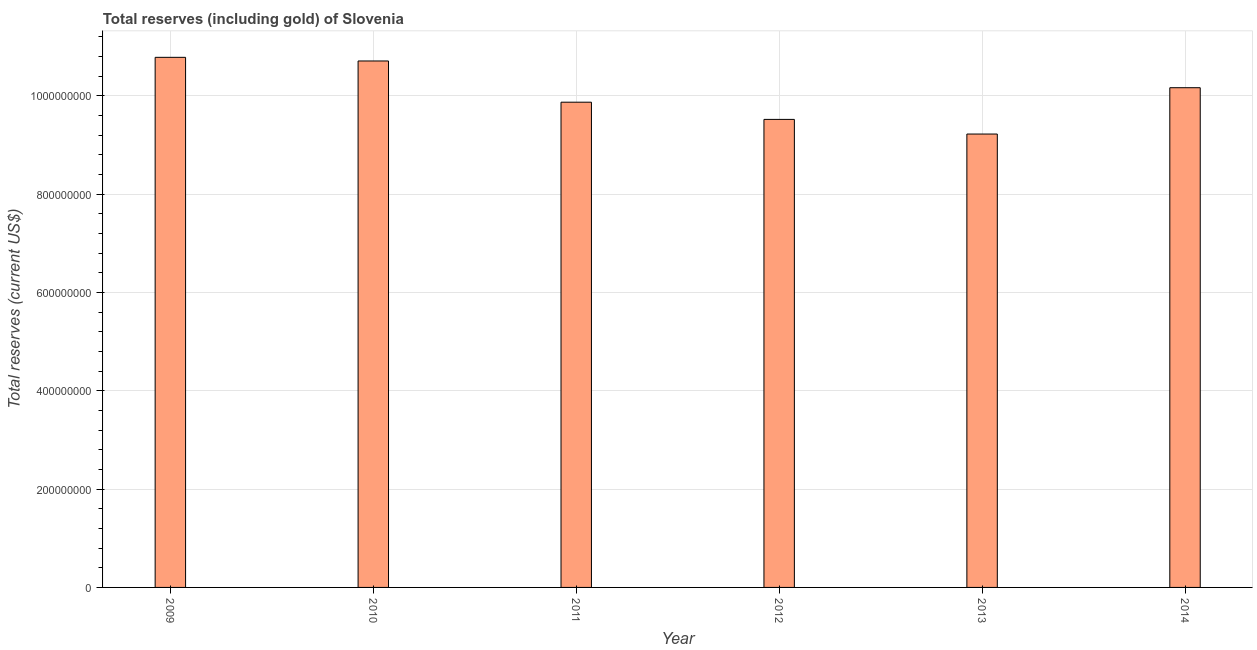Does the graph contain grids?
Provide a succinct answer. Yes. What is the title of the graph?
Provide a short and direct response. Total reserves (including gold) of Slovenia. What is the label or title of the Y-axis?
Make the answer very short. Total reserves (current US$). What is the total reserves (including gold) in 2012?
Make the answer very short. 9.52e+08. Across all years, what is the maximum total reserves (including gold)?
Provide a succinct answer. 1.08e+09. Across all years, what is the minimum total reserves (including gold)?
Your response must be concise. 9.22e+08. In which year was the total reserves (including gold) maximum?
Provide a short and direct response. 2009. In which year was the total reserves (including gold) minimum?
Provide a short and direct response. 2013. What is the sum of the total reserves (including gold)?
Ensure brevity in your answer.  6.03e+09. What is the difference between the total reserves (including gold) in 2009 and 2011?
Keep it short and to the point. 9.13e+07. What is the average total reserves (including gold) per year?
Provide a succinct answer. 1.00e+09. What is the median total reserves (including gold)?
Offer a terse response. 1.00e+09. Do a majority of the years between 2014 and 2011 (inclusive) have total reserves (including gold) greater than 120000000 US$?
Keep it short and to the point. Yes. What is the ratio of the total reserves (including gold) in 2009 to that in 2011?
Your response must be concise. 1.09. Is the difference between the total reserves (including gold) in 2010 and 2014 greater than the difference between any two years?
Give a very brief answer. No. What is the difference between the highest and the second highest total reserves (including gold)?
Offer a very short reply. 7.40e+06. Is the sum of the total reserves (including gold) in 2012 and 2014 greater than the maximum total reserves (including gold) across all years?
Provide a succinct answer. Yes. What is the difference between the highest and the lowest total reserves (including gold)?
Your answer should be compact. 1.56e+08. In how many years, is the total reserves (including gold) greater than the average total reserves (including gold) taken over all years?
Make the answer very short. 3. How many bars are there?
Make the answer very short. 6. How many years are there in the graph?
Offer a terse response. 6. What is the Total reserves (current US$) in 2009?
Provide a short and direct response. 1.08e+09. What is the Total reserves (current US$) of 2010?
Your response must be concise. 1.07e+09. What is the Total reserves (current US$) in 2011?
Your response must be concise. 9.87e+08. What is the Total reserves (current US$) in 2012?
Ensure brevity in your answer.  9.52e+08. What is the Total reserves (current US$) in 2013?
Your response must be concise. 9.22e+08. What is the Total reserves (current US$) in 2014?
Your response must be concise. 1.02e+09. What is the difference between the Total reserves (current US$) in 2009 and 2010?
Give a very brief answer. 7.40e+06. What is the difference between the Total reserves (current US$) in 2009 and 2011?
Ensure brevity in your answer.  9.13e+07. What is the difference between the Total reserves (current US$) in 2009 and 2012?
Offer a very short reply. 1.26e+08. What is the difference between the Total reserves (current US$) in 2009 and 2013?
Your response must be concise. 1.56e+08. What is the difference between the Total reserves (current US$) in 2009 and 2014?
Ensure brevity in your answer.  6.18e+07. What is the difference between the Total reserves (current US$) in 2010 and 2011?
Offer a terse response. 8.39e+07. What is the difference between the Total reserves (current US$) in 2010 and 2012?
Provide a short and direct response. 1.19e+08. What is the difference between the Total reserves (current US$) in 2010 and 2013?
Your answer should be very brief. 1.49e+08. What is the difference between the Total reserves (current US$) in 2010 and 2014?
Provide a succinct answer. 5.44e+07. What is the difference between the Total reserves (current US$) in 2011 and 2012?
Make the answer very short. 3.50e+07. What is the difference between the Total reserves (current US$) in 2011 and 2013?
Your answer should be compact. 6.47e+07. What is the difference between the Total reserves (current US$) in 2011 and 2014?
Provide a short and direct response. -2.95e+07. What is the difference between the Total reserves (current US$) in 2012 and 2013?
Offer a very short reply. 2.98e+07. What is the difference between the Total reserves (current US$) in 2012 and 2014?
Offer a very short reply. -6.45e+07. What is the difference between the Total reserves (current US$) in 2013 and 2014?
Ensure brevity in your answer.  -9.42e+07. What is the ratio of the Total reserves (current US$) in 2009 to that in 2010?
Give a very brief answer. 1.01. What is the ratio of the Total reserves (current US$) in 2009 to that in 2011?
Make the answer very short. 1.09. What is the ratio of the Total reserves (current US$) in 2009 to that in 2012?
Keep it short and to the point. 1.13. What is the ratio of the Total reserves (current US$) in 2009 to that in 2013?
Provide a succinct answer. 1.17. What is the ratio of the Total reserves (current US$) in 2009 to that in 2014?
Your answer should be very brief. 1.06. What is the ratio of the Total reserves (current US$) in 2010 to that in 2011?
Offer a terse response. 1.08. What is the ratio of the Total reserves (current US$) in 2010 to that in 2012?
Offer a terse response. 1.12. What is the ratio of the Total reserves (current US$) in 2010 to that in 2013?
Your response must be concise. 1.16. What is the ratio of the Total reserves (current US$) in 2010 to that in 2014?
Keep it short and to the point. 1.05. What is the ratio of the Total reserves (current US$) in 2011 to that in 2013?
Your response must be concise. 1.07. What is the ratio of the Total reserves (current US$) in 2012 to that in 2013?
Your response must be concise. 1.03. What is the ratio of the Total reserves (current US$) in 2012 to that in 2014?
Your response must be concise. 0.94. What is the ratio of the Total reserves (current US$) in 2013 to that in 2014?
Provide a short and direct response. 0.91. 